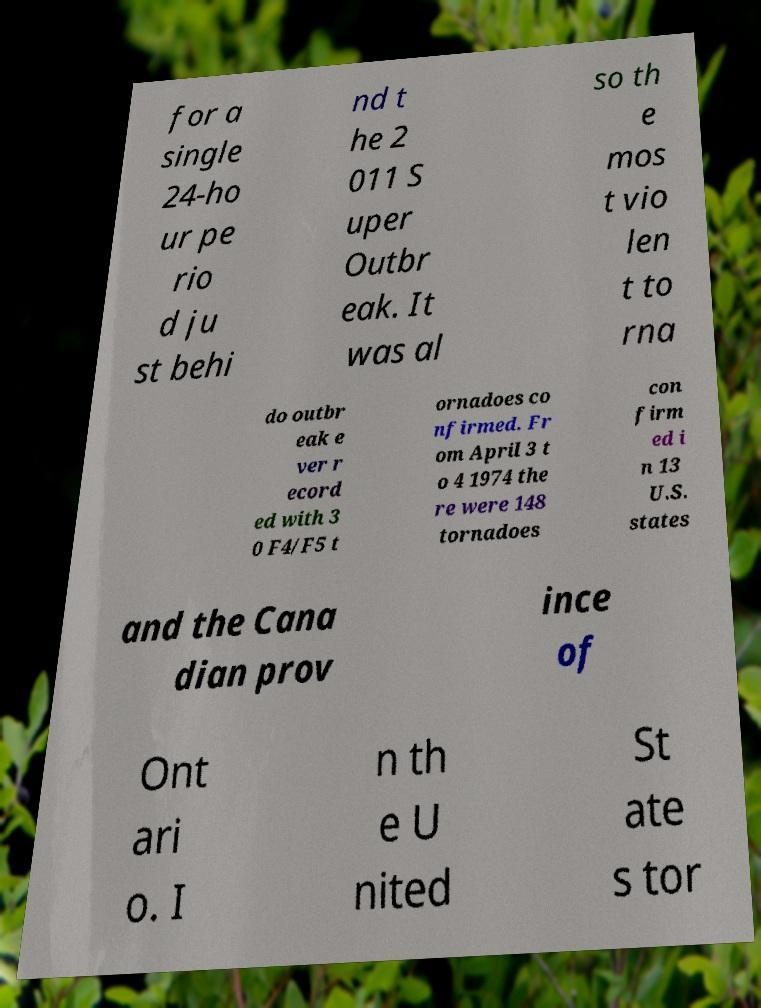I need the written content from this picture converted into text. Can you do that? for a single 24-ho ur pe rio d ju st behi nd t he 2 011 S uper Outbr eak. It was al so th e mos t vio len t to rna do outbr eak e ver r ecord ed with 3 0 F4/F5 t ornadoes co nfirmed. Fr om April 3 t o 4 1974 the re were 148 tornadoes con firm ed i n 13 U.S. states and the Cana dian prov ince of Ont ari o. I n th e U nited St ate s tor 